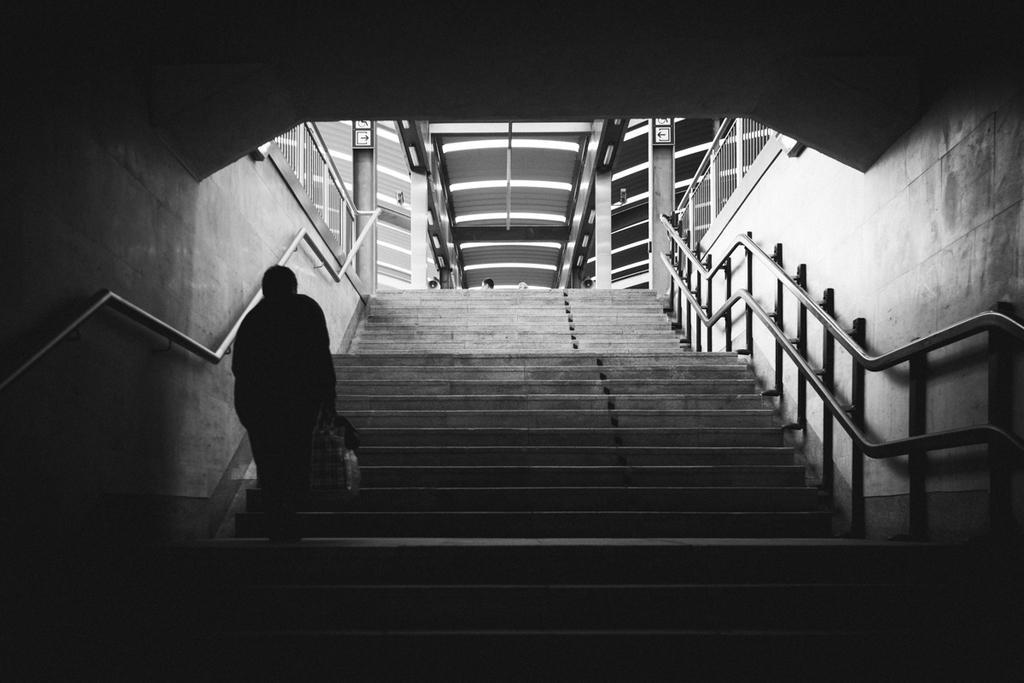Please provide a concise description of this image. This is a black and white image. There are stairs in the middle. There is a person on the left side. 